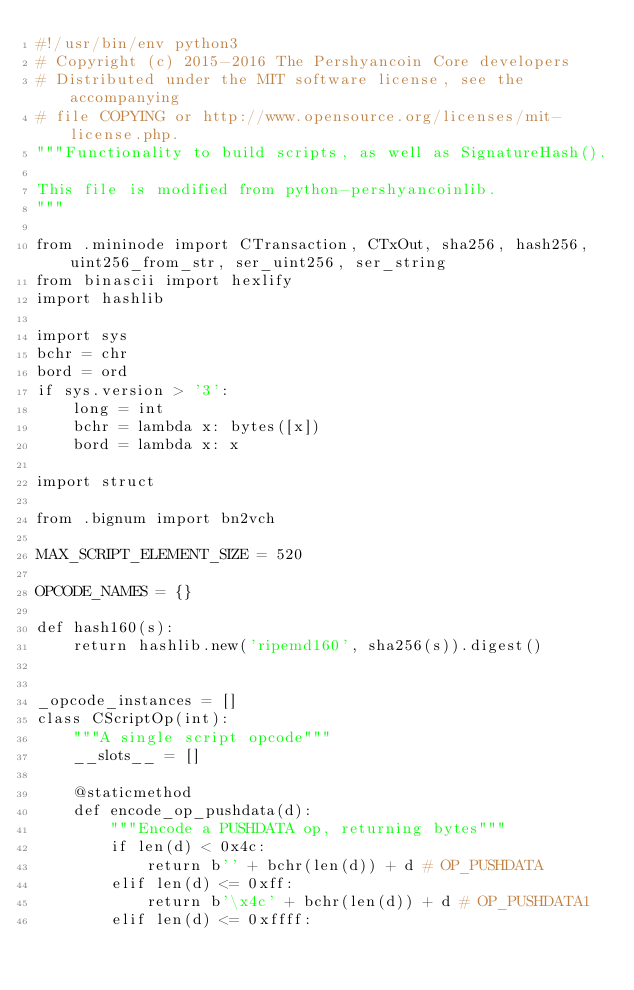<code> <loc_0><loc_0><loc_500><loc_500><_Python_>#!/usr/bin/env python3
# Copyright (c) 2015-2016 The Pershyancoin Core developers
# Distributed under the MIT software license, see the accompanying
# file COPYING or http://www.opensource.org/licenses/mit-license.php.
"""Functionality to build scripts, as well as SignatureHash().

This file is modified from python-pershyancoinlib.
"""

from .mininode import CTransaction, CTxOut, sha256, hash256, uint256_from_str, ser_uint256, ser_string
from binascii import hexlify
import hashlib

import sys
bchr = chr
bord = ord
if sys.version > '3':
    long = int
    bchr = lambda x: bytes([x])
    bord = lambda x: x

import struct

from .bignum import bn2vch

MAX_SCRIPT_ELEMENT_SIZE = 520

OPCODE_NAMES = {}

def hash160(s):
    return hashlib.new('ripemd160', sha256(s)).digest()


_opcode_instances = []
class CScriptOp(int):
    """A single script opcode"""
    __slots__ = []

    @staticmethod
    def encode_op_pushdata(d):
        """Encode a PUSHDATA op, returning bytes"""
        if len(d) < 0x4c:
            return b'' + bchr(len(d)) + d # OP_PUSHDATA
        elif len(d) <= 0xff:
            return b'\x4c' + bchr(len(d)) + d # OP_PUSHDATA1
        elif len(d) <= 0xffff:</code> 